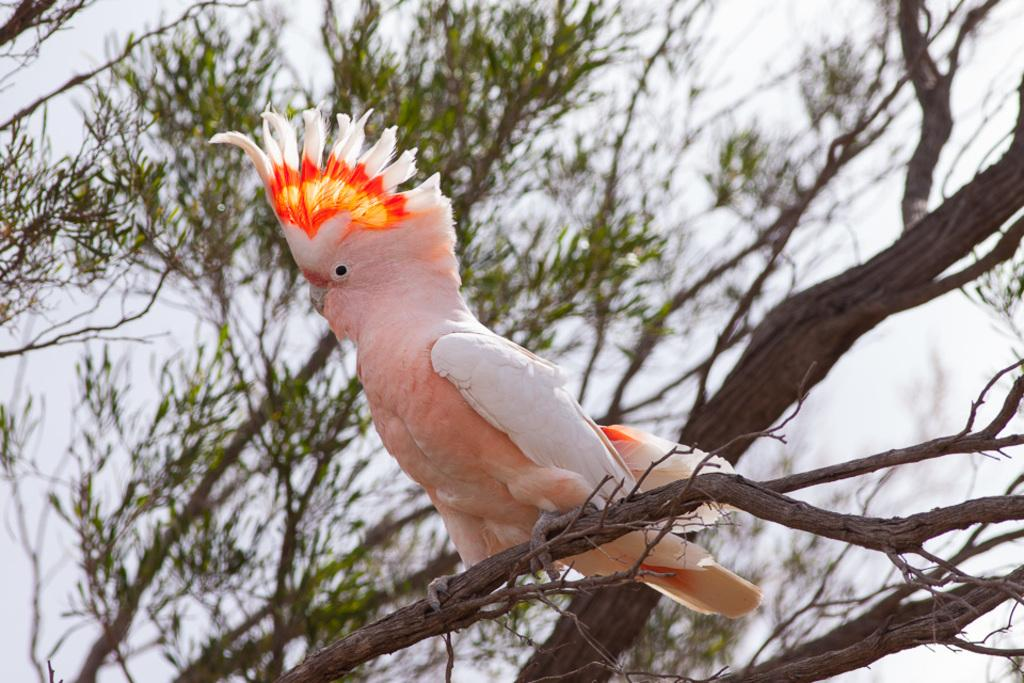What type of bird is in the image? There is a cockatoo bird in the image. Where is the bird located in the image? The bird is standing on a tree branch. What else can be seen in the image besides the bird? There is a tree in the image. What can be seen in the background of the image? The sky is visible in the background of the image. What type of mint is growing on the tree branch in the image? There is no mint plant visible in the image; it features a cockatoo bird standing on a tree branch. 